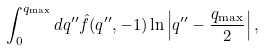<formula> <loc_0><loc_0><loc_500><loc_500>\int ^ { q _ { \max } } _ { 0 } d q ^ { \prime \prime } \hat { f } ( q ^ { \prime \prime } , - 1 ) \ln \left | q ^ { \prime \prime } - \frac { q _ { \max } } { 2 } \right | ,</formula> 